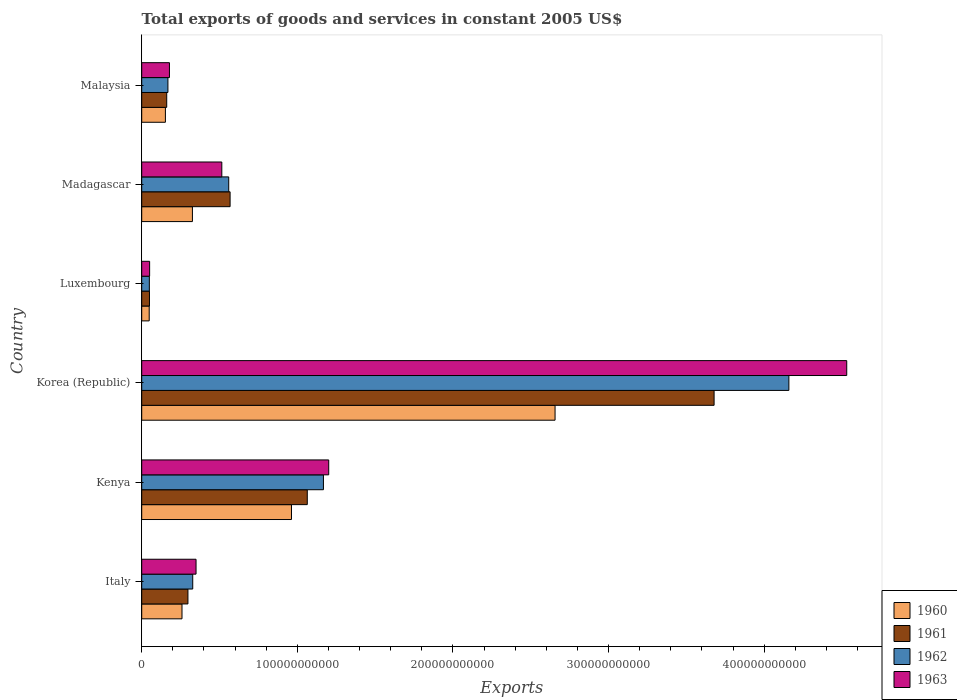How many groups of bars are there?
Your answer should be compact. 6. Are the number of bars on each tick of the Y-axis equal?
Your response must be concise. Yes. What is the label of the 2nd group of bars from the top?
Make the answer very short. Madagascar. In how many cases, is the number of bars for a given country not equal to the number of legend labels?
Offer a terse response. 0. What is the total exports of goods and services in 1960 in Luxembourg?
Provide a succinct answer. 4.81e+09. Across all countries, what is the maximum total exports of goods and services in 1961?
Your answer should be compact. 3.68e+11. Across all countries, what is the minimum total exports of goods and services in 1963?
Your response must be concise. 5.08e+09. In which country was the total exports of goods and services in 1961 maximum?
Make the answer very short. Korea (Republic). In which country was the total exports of goods and services in 1960 minimum?
Ensure brevity in your answer.  Luxembourg. What is the total total exports of goods and services in 1961 in the graph?
Make the answer very short. 5.82e+11. What is the difference between the total exports of goods and services in 1961 in Korea (Republic) and that in Luxembourg?
Offer a very short reply. 3.63e+11. What is the difference between the total exports of goods and services in 1963 in Italy and the total exports of goods and services in 1960 in Korea (Republic)?
Ensure brevity in your answer.  -2.31e+11. What is the average total exports of goods and services in 1960 per country?
Your answer should be compact. 7.34e+1. What is the difference between the total exports of goods and services in 1961 and total exports of goods and services in 1960 in Madagascar?
Your response must be concise. 2.42e+1. In how many countries, is the total exports of goods and services in 1960 greater than 100000000000 US$?
Provide a short and direct response. 1. What is the ratio of the total exports of goods and services in 1960 in Kenya to that in Luxembourg?
Ensure brevity in your answer.  20.01. Is the difference between the total exports of goods and services in 1961 in Kenya and Madagascar greater than the difference between the total exports of goods and services in 1960 in Kenya and Madagascar?
Offer a terse response. No. What is the difference between the highest and the second highest total exports of goods and services in 1963?
Your response must be concise. 3.33e+11. What is the difference between the highest and the lowest total exports of goods and services in 1963?
Keep it short and to the point. 4.48e+11. What does the 3rd bar from the top in Malaysia represents?
Provide a succinct answer. 1961. Is it the case that in every country, the sum of the total exports of goods and services in 1962 and total exports of goods and services in 1961 is greater than the total exports of goods and services in 1960?
Provide a succinct answer. Yes. How many countries are there in the graph?
Make the answer very short. 6. What is the difference between two consecutive major ticks on the X-axis?
Keep it short and to the point. 1.00e+11. Are the values on the major ticks of X-axis written in scientific E-notation?
Keep it short and to the point. No. How are the legend labels stacked?
Ensure brevity in your answer.  Vertical. What is the title of the graph?
Provide a short and direct response. Total exports of goods and services in constant 2005 US$. Does "1983" appear as one of the legend labels in the graph?
Offer a terse response. No. What is the label or title of the X-axis?
Provide a succinct answer. Exports. What is the label or title of the Y-axis?
Ensure brevity in your answer.  Country. What is the Exports of 1960 in Italy?
Offer a terse response. 2.59e+1. What is the Exports in 1961 in Italy?
Your answer should be very brief. 2.97e+1. What is the Exports of 1962 in Italy?
Your answer should be compact. 3.28e+1. What is the Exports of 1963 in Italy?
Your answer should be compact. 3.49e+1. What is the Exports of 1960 in Kenya?
Provide a succinct answer. 9.62e+1. What is the Exports in 1961 in Kenya?
Make the answer very short. 1.06e+11. What is the Exports in 1962 in Kenya?
Make the answer very short. 1.17e+11. What is the Exports of 1963 in Kenya?
Ensure brevity in your answer.  1.20e+11. What is the Exports in 1960 in Korea (Republic)?
Give a very brief answer. 2.66e+11. What is the Exports of 1961 in Korea (Republic)?
Provide a short and direct response. 3.68e+11. What is the Exports of 1962 in Korea (Republic)?
Ensure brevity in your answer.  4.16e+11. What is the Exports of 1963 in Korea (Republic)?
Your answer should be very brief. 4.53e+11. What is the Exports of 1960 in Luxembourg?
Provide a succinct answer. 4.81e+09. What is the Exports in 1961 in Luxembourg?
Offer a terse response. 4.98e+09. What is the Exports in 1962 in Luxembourg?
Give a very brief answer. 4.90e+09. What is the Exports of 1963 in Luxembourg?
Your response must be concise. 5.08e+09. What is the Exports in 1960 in Madagascar?
Your answer should be very brief. 3.26e+1. What is the Exports in 1961 in Madagascar?
Your answer should be very brief. 5.68e+1. What is the Exports in 1962 in Madagascar?
Provide a short and direct response. 5.59e+1. What is the Exports of 1963 in Madagascar?
Offer a terse response. 5.15e+1. What is the Exports of 1960 in Malaysia?
Offer a terse response. 1.52e+1. What is the Exports of 1961 in Malaysia?
Give a very brief answer. 1.61e+1. What is the Exports in 1962 in Malaysia?
Make the answer very short. 1.68e+1. What is the Exports of 1963 in Malaysia?
Keep it short and to the point. 1.78e+1. Across all countries, what is the maximum Exports of 1960?
Your answer should be very brief. 2.66e+11. Across all countries, what is the maximum Exports of 1961?
Ensure brevity in your answer.  3.68e+11. Across all countries, what is the maximum Exports in 1962?
Give a very brief answer. 4.16e+11. Across all countries, what is the maximum Exports of 1963?
Offer a very short reply. 4.53e+11. Across all countries, what is the minimum Exports of 1960?
Offer a terse response. 4.81e+09. Across all countries, what is the minimum Exports in 1961?
Your answer should be very brief. 4.98e+09. Across all countries, what is the minimum Exports in 1962?
Provide a succinct answer. 4.90e+09. Across all countries, what is the minimum Exports in 1963?
Your response must be concise. 5.08e+09. What is the total Exports of 1960 in the graph?
Give a very brief answer. 4.40e+11. What is the total Exports in 1961 in the graph?
Your answer should be very brief. 5.82e+11. What is the total Exports of 1962 in the graph?
Your answer should be very brief. 6.43e+11. What is the total Exports of 1963 in the graph?
Make the answer very short. 6.82e+11. What is the difference between the Exports of 1960 in Italy and that in Kenya?
Give a very brief answer. -7.04e+1. What is the difference between the Exports in 1961 in Italy and that in Kenya?
Ensure brevity in your answer.  -7.67e+1. What is the difference between the Exports of 1962 in Italy and that in Kenya?
Your response must be concise. -8.40e+1. What is the difference between the Exports in 1963 in Italy and that in Kenya?
Your response must be concise. -8.53e+1. What is the difference between the Exports of 1960 in Italy and that in Korea (Republic)?
Offer a terse response. -2.40e+11. What is the difference between the Exports of 1961 in Italy and that in Korea (Republic)?
Offer a very short reply. -3.38e+11. What is the difference between the Exports of 1962 in Italy and that in Korea (Republic)?
Offer a terse response. -3.83e+11. What is the difference between the Exports in 1963 in Italy and that in Korea (Republic)?
Provide a short and direct response. -4.18e+11. What is the difference between the Exports in 1960 in Italy and that in Luxembourg?
Keep it short and to the point. 2.11e+1. What is the difference between the Exports in 1961 in Italy and that in Luxembourg?
Your answer should be very brief. 2.47e+1. What is the difference between the Exports in 1962 in Italy and that in Luxembourg?
Provide a succinct answer. 2.79e+1. What is the difference between the Exports of 1963 in Italy and that in Luxembourg?
Your answer should be compact. 2.98e+1. What is the difference between the Exports of 1960 in Italy and that in Madagascar?
Offer a terse response. -6.70e+09. What is the difference between the Exports in 1961 in Italy and that in Madagascar?
Your response must be concise. -2.71e+1. What is the difference between the Exports in 1962 in Italy and that in Madagascar?
Provide a short and direct response. -2.31e+1. What is the difference between the Exports of 1963 in Italy and that in Madagascar?
Your answer should be very brief. -1.66e+1. What is the difference between the Exports in 1960 in Italy and that in Malaysia?
Give a very brief answer. 1.07e+1. What is the difference between the Exports of 1961 in Italy and that in Malaysia?
Provide a short and direct response. 1.36e+1. What is the difference between the Exports of 1962 in Italy and that in Malaysia?
Provide a succinct answer. 1.59e+1. What is the difference between the Exports of 1963 in Italy and that in Malaysia?
Keep it short and to the point. 1.71e+1. What is the difference between the Exports of 1960 in Kenya and that in Korea (Republic)?
Your answer should be compact. -1.69e+11. What is the difference between the Exports of 1961 in Kenya and that in Korea (Republic)?
Keep it short and to the point. -2.61e+11. What is the difference between the Exports of 1962 in Kenya and that in Korea (Republic)?
Provide a short and direct response. -2.99e+11. What is the difference between the Exports in 1963 in Kenya and that in Korea (Republic)?
Give a very brief answer. -3.33e+11. What is the difference between the Exports of 1960 in Kenya and that in Luxembourg?
Offer a terse response. 9.14e+1. What is the difference between the Exports in 1961 in Kenya and that in Luxembourg?
Provide a succinct answer. 1.01e+11. What is the difference between the Exports in 1962 in Kenya and that in Luxembourg?
Offer a very short reply. 1.12e+11. What is the difference between the Exports of 1963 in Kenya and that in Luxembourg?
Offer a very short reply. 1.15e+11. What is the difference between the Exports in 1960 in Kenya and that in Madagascar?
Your response must be concise. 6.37e+1. What is the difference between the Exports in 1961 in Kenya and that in Madagascar?
Give a very brief answer. 4.96e+1. What is the difference between the Exports of 1962 in Kenya and that in Madagascar?
Offer a very short reply. 6.09e+1. What is the difference between the Exports of 1963 in Kenya and that in Madagascar?
Keep it short and to the point. 6.87e+1. What is the difference between the Exports of 1960 in Kenya and that in Malaysia?
Give a very brief answer. 8.10e+1. What is the difference between the Exports in 1961 in Kenya and that in Malaysia?
Make the answer very short. 9.03e+1. What is the difference between the Exports of 1962 in Kenya and that in Malaysia?
Ensure brevity in your answer.  9.99e+1. What is the difference between the Exports in 1963 in Kenya and that in Malaysia?
Your answer should be very brief. 1.02e+11. What is the difference between the Exports in 1960 in Korea (Republic) and that in Luxembourg?
Your answer should be very brief. 2.61e+11. What is the difference between the Exports of 1961 in Korea (Republic) and that in Luxembourg?
Offer a terse response. 3.63e+11. What is the difference between the Exports in 1962 in Korea (Republic) and that in Luxembourg?
Ensure brevity in your answer.  4.11e+11. What is the difference between the Exports of 1963 in Korea (Republic) and that in Luxembourg?
Provide a short and direct response. 4.48e+11. What is the difference between the Exports of 1960 in Korea (Republic) and that in Madagascar?
Your answer should be compact. 2.33e+11. What is the difference between the Exports of 1961 in Korea (Republic) and that in Madagascar?
Give a very brief answer. 3.11e+11. What is the difference between the Exports in 1962 in Korea (Republic) and that in Madagascar?
Make the answer very short. 3.60e+11. What is the difference between the Exports in 1963 in Korea (Republic) and that in Madagascar?
Your response must be concise. 4.02e+11. What is the difference between the Exports of 1960 in Korea (Republic) and that in Malaysia?
Your response must be concise. 2.50e+11. What is the difference between the Exports of 1961 in Korea (Republic) and that in Malaysia?
Keep it short and to the point. 3.52e+11. What is the difference between the Exports of 1962 in Korea (Republic) and that in Malaysia?
Ensure brevity in your answer.  3.99e+11. What is the difference between the Exports of 1963 in Korea (Republic) and that in Malaysia?
Your response must be concise. 4.35e+11. What is the difference between the Exports in 1960 in Luxembourg and that in Madagascar?
Your answer should be compact. -2.78e+1. What is the difference between the Exports of 1961 in Luxembourg and that in Madagascar?
Keep it short and to the point. -5.18e+1. What is the difference between the Exports of 1962 in Luxembourg and that in Madagascar?
Make the answer very short. -5.10e+1. What is the difference between the Exports in 1963 in Luxembourg and that in Madagascar?
Your response must be concise. -4.64e+1. What is the difference between the Exports of 1960 in Luxembourg and that in Malaysia?
Provide a short and direct response. -1.04e+1. What is the difference between the Exports in 1961 in Luxembourg and that in Malaysia?
Your answer should be very brief. -1.11e+1. What is the difference between the Exports of 1962 in Luxembourg and that in Malaysia?
Provide a short and direct response. -1.19e+1. What is the difference between the Exports in 1963 in Luxembourg and that in Malaysia?
Give a very brief answer. -1.27e+1. What is the difference between the Exports in 1960 in Madagascar and that in Malaysia?
Ensure brevity in your answer.  1.74e+1. What is the difference between the Exports of 1961 in Madagascar and that in Malaysia?
Your response must be concise. 4.07e+1. What is the difference between the Exports of 1962 in Madagascar and that in Malaysia?
Offer a terse response. 3.91e+1. What is the difference between the Exports of 1963 in Madagascar and that in Malaysia?
Offer a very short reply. 3.36e+1. What is the difference between the Exports in 1960 in Italy and the Exports in 1961 in Kenya?
Provide a succinct answer. -8.05e+1. What is the difference between the Exports in 1960 in Italy and the Exports in 1962 in Kenya?
Your response must be concise. -9.09e+1. What is the difference between the Exports of 1960 in Italy and the Exports of 1963 in Kenya?
Offer a very short reply. -9.43e+1. What is the difference between the Exports of 1961 in Italy and the Exports of 1962 in Kenya?
Provide a short and direct response. -8.71e+1. What is the difference between the Exports of 1961 in Italy and the Exports of 1963 in Kenya?
Provide a short and direct response. -9.05e+1. What is the difference between the Exports of 1962 in Italy and the Exports of 1963 in Kenya?
Your answer should be compact. -8.74e+1. What is the difference between the Exports in 1960 in Italy and the Exports in 1961 in Korea (Republic)?
Your response must be concise. -3.42e+11. What is the difference between the Exports in 1960 in Italy and the Exports in 1962 in Korea (Republic)?
Your answer should be very brief. -3.90e+11. What is the difference between the Exports of 1960 in Italy and the Exports of 1963 in Korea (Republic)?
Your response must be concise. -4.27e+11. What is the difference between the Exports of 1961 in Italy and the Exports of 1962 in Korea (Republic)?
Your answer should be compact. -3.86e+11. What is the difference between the Exports of 1961 in Italy and the Exports of 1963 in Korea (Republic)?
Your response must be concise. -4.23e+11. What is the difference between the Exports in 1962 in Italy and the Exports in 1963 in Korea (Republic)?
Your answer should be very brief. -4.20e+11. What is the difference between the Exports of 1960 in Italy and the Exports of 1961 in Luxembourg?
Offer a terse response. 2.09e+1. What is the difference between the Exports in 1960 in Italy and the Exports in 1962 in Luxembourg?
Provide a short and direct response. 2.10e+1. What is the difference between the Exports in 1960 in Italy and the Exports in 1963 in Luxembourg?
Offer a terse response. 2.08e+1. What is the difference between the Exports in 1961 in Italy and the Exports in 1962 in Luxembourg?
Provide a succinct answer. 2.48e+1. What is the difference between the Exports in 1961 in Italy and the Exports in 1963 in Luxembourg?
Make the answer very short. 2.46e+1. What is the difference between the Exports in 1962 in Italy and the Exports in 1963 in Luxembourg?
Ensure brevity in your answer.  2.77e+1. What is the difference between the Exports of 1960 in Italy and the Exports of 1961 in Madagascar?
Offer a very short reply. -3.09e+1. What is the difference between the Exports of 1960 in Italy and the Exports of 1962 in Madagascar?
Your answer should be compact. -3.00e+1. What is the difference between the Exports in 1960 in Italy and the Exports in 1963 in Madagascar?
Your answer should be compact. -2.56e+1. What is the difference between the Exports in 1961 in Italy and the Exports in 1962 in Madagascar?
Make the answer very short. -2.62e+1. What is the difference between the Exports in 1961 in Italy and the Exports in 1963 in Madagascar?
Your answer should be very brief. -2.18e+1. What is the difference between the Exports in 1962 in Italy and the Exports in 1963 in Madagascar?
Provide a succinct answer. -1.87e+1. What is the difference between the Exports in 1960 in Italy and the Exports in 1961 in Malaysia?
Provide a short and direct response. 9.82e+09. What is the difference between the Exports in 1960 in Italy and the Exports in 1962 in Malaysia?
Provide a succinct answer. 9.05e+09. What is the difference between the Exports in 1960 in Italy and the Exports in 1963 in Malaysia?
Keep it short and to the point. 8.06e+09. What is the difference between the Exports of 1961 in Italy and the Exports of 1962 in Malaysia?
Your response must be concise. 1.29e+1. What is the difference between the Exports in 1961 in Italy and the Exports in 1963 in Malaysia?
Provide a succinct answer. 1.19e+1. What is the difference between the Exports in 1962 in Italy and the Exports in 1963 in Malaysia?
Keep it short and to the point. 1.50e+1. What is the difference between the Exports in 1960 in Kenya and the Exports in 1961 in Korea (Republic)?
Your answer should be compact. -2.72e+11. What is the difference between the Exports of 1960 in Kenya and the Exports of 1962 in Korea (Republic)?
Make the answer very short. -3.20e+11. What is the difference between the Exports of 1960 in Kenya and the Exports of 1963 in Korea (Republic)?
Provide a short and direct response. -3.57e+11. What is the difference between the Exports of 1961 in Kenya and the Exports of 1962 in Korea (Republic)?
Give a very brief answer. -3.09e+11. What is the difference between the Exports of 1961 in Kenya and the Exports of 1963 in Korea (Republic)?
Give a very brief answer. -3.47e+11. What is the difference between the Exports in 1962 in Kenya and the Exports in 1963 in Korea (Republic)?
Your response must be concise. -3.36e+11. What is the difference between the Exports in 1960 in Kenya and the Exports in 1961 in Luxembourg?
Your response must be concise. 9.13e+1. What is the difference between the Exports of 1960 in Kenya and the Exports of 1962 in Luxembourg?
Your answer should be compact. 9.13e+1. What is the difference between the Exports of 1960 in Kenya and the Exports of 1963 in Luxembourg?
Offer a very short reply. 9.12e+1. What is the difference between the Exports in 1961 in Kenya and the Exports in 1962 in Luxembourg?
Ensure brevity in your answer.  1.01e+11. What is the difference between the Exports in 1961 in Kenya and the Exports in 1963 in Luxembourg?
Offer a terse response. 1.01e+11. What is the difference between the Exports in 1962 in Kenya and the Exports in 1963 in Luxembourg?
Provide a succinct answer. 1.12e+11. What is the difference between the Exports of 1960 in Kenya and the Exports of 1961 in Madagascar?
Make the answer very short. 3.94e+1. What is the difference between the Exports of 1960 in Kenya and the Exports of 1962 in Madagascar?
Offer a terse response. 4.03e+1. What is the difference between the Exports in 1960 in Kenya and the Exports in 1963 in Madagascar?
Your response must be concise. 4.48e+1. What is the difference between the Exports in 1961 in Kenya and the Exports in 1962 in Madagascar?
Your answer should be compact. 5.05e+1. What is the difference between the Exports of 1961 in Kenya and the Exports of 1963 in Madagascar?
Make the answer very short. 5.49e+1. What is the difference between the Exports in 1962 in Kenya and the Exports in 1963 in Madagascar?
Your response must be concise. 6.53e+1. What is the difference between the Exports in 1960 in Kenya and the Exports in 1961 in Malaysia?
Give a very brief answer. 8.02e+1. What is the difference between the Exports in 1960 in Kenya and the Exports in 1962 in Malaysia?
Provide a succinct answer. 7.94e+1. What is the difference between the Exports in 1960 in Kenya and the Exports in 1963 in Malaysia?
Ensure brevity in your answer.  7.84e+1. What is the difference between the Exports of 1961 in Kenya and the Exports of 1962 in Malaysia?
Provide a succinct answer. 8.96e+1. What is the difference between the Exports of 1961 in Kenya and the Exports of 1963 in Malaysia?
Make the answer very short. 8.86e+1. What is the difference between the Exports of 1962 in Kenya and the Exports of 1963 in Malaysia?
Ensure brevity in your answer.  9.89e+1. What is the difference between the Exports of 1960 in Korea (Republic) and the Exports of 1961 in Luxembourg?
Make the answer very short. 2.61e+11. What is the difference between the Exports in 1960 in Korea (Republic) and the Exports in 1962 in Luxembourg?
Your answer should be very brief. 2.61e+11. What is the difference between the Exports of 1960 in Korea (Republic) and the Exports of 1963 in Luxembourg?
Keep it short and to the point. 2.61e+11. What is the difference between the Exports in 1961 in Korea (Republic) and the Exports in 1962 in Luxembourg?
Provide a succinct answer. 3.63e+11. What is the difference between the Exports of 1961 in Korea (Republic) and the Exports of 1963 in Luxembourg?
Ensure brevity in your answer.  3.63e+11. What is the difference between the Exports in 1962 in Korea (Republic) and the Exports in 1963 in Luxembourg?
Provide a short and direct response. 4.11e+11. What is the difference between the Exports of 1960 in Korea (Republic) and the Exports of 1961 in Madagascar?
Your answer should be compact. 2.09e+11. What is the difference between the Exports in 1960 in Korea (Republic) and the Exports in 1962 in Madagascar?
Provide a succinct answer. 2.10e+11. What is the difference between the Exports in 1960 in Korea (Republic) and the Exports in 1963 in Madagascar?
Make the answer very short. 2.14e+11. What is the difference between the Exports of 1961 in Korea (Republic) and the Exports of 1962 in Madagascar?
Keep it short and to the point. 3.12e+11. What is the difference between the Exports of 1961 in Korea (Republic) and the Exports of 1963 in Madagascar?
Offer a very short reply. 3.16e+11. What is the difference between the Exports of 1962 in Korea (Republic) and the Exports of 1963 in Madagascar?
Give a very brief answer. 3.64e+11. What is the difference between the Exports in 1960 in Korea (Republic) and the Exports in 1961 in Malaysia?
Offer a terse response. 2.50e+11. What is the difference between the Exports in 1960 in Korea (Republic) and the Exports in 1962 in Malaysia?
Keep it short and to the point. 2.49e+11. What is the difference between the Exports in 1960 in Korea (Republic) and the Exports in 1963 in Malaysia?
Provide a succinct answer. 2.48e+11. What is the difference between the Exports in 1961 in Korea (Republic) and the Exports in 1962 in Malaysia?
Offer a terse response. 3.51e+11. What is the difference between the Exports of 1961 in Korea (Republic) and the Exports of 1963 in Malaysia?
Give a very brief answer. 3.50e+11. What is the difference between the Exports in 1962 in Korea (Republic) and the Exports in 1963 in Malaysia?
Offer a terse response. 3.98e+11. What is the difference between the Exports in 1960 in Luxembourg and the Exports in 1961 in Madagascar?
Keep it short and to the point. -5.20e+1. What is the difference between the Exports of 1960 in Luxembourg and the Exports of 1962 in Madagascar?
Make the answer very short. -5.11e+1. What is the difference between the Exports in 1960 in Luxembourg and the Exports in 1963 in Madagascar?
Offer a very short reply. -4.67e+1. What is the difference between the Exports in 1961 in Luxembourg and the Exports in 1962 in Madagascar?
Keep it short and to the point. -5.09e+1. What is the difference between the Exports in 1961 in Luxembourg and the Exports in 1963 in Madagascar?
Offer a terse response. -4.65e+1. What is the difference between the Exports in 1962 in Luxembourg and the Exports in 1963 in Madagascar?
Your answer should be very brief. -4.66e+1. What is the difference between the Exports in 1960 in Luxembourg and the Exports in 1961 in Malaysia?
Keep it short and to the point. -1.13e+1. What is the difference between the Exports in 1960 in Luxembourg and the Exports in 1962 in Malaysia?
Offer a very short reply. -1.20e+1. What is the difference between the Exports of 1960 in Luxembourg and the Exports of 1963 in Malaysia?
Offer a terse response. -1.30e+1. What is the difference between the Exports in 1961 in Luxembourg and the Exports in 1962 in Malaysia?
Keep it short and to the point. -1.19e+1. What is the difference between the Exports of 1961 in Luxembourg and the Exports of 1963 in Malaysia?
Ensure brevity in your answer.  -1.28e+1. What is the difference between the Exports of 1962 in Luxembourg and the Exports of 1963 in Malaysia?
Offer a terse response. -1.29e+1. What is the difference between the Exports in 1960 in Madagascar and the Exports in 1961 in Malaysia?
Your answer should be compact. 1.65e+1. What is the difference between the Exports of 1960 in Madagascar and the Exports of 1962 in Malaysia?
Provide a short and direct response. 1.57e+1. What is the difference between the Exports of 1960 in Madagascar and the Exports of 1963 in Malaysia?
Offer a terse response. 1.48e+1. What is the difference between the Exports in 1961 in Madagascar and the Exports in 1962 in Malaysia?
Provide a short and direct response. 4.00e+1. What is the difference between the Exports of 1961 in Madagascar and the Exports of 1963 in Malaysia?
Give a very brief answer. 3.90e+1. What is the difference between the Exports in 1962 in Madagascar and the Exports in 1963 in Malaysia?
Your answer should be very brief. 3.81e+1. What is the average Exports of 1960 per country?
Give a very brief answer. 7.34e+1. What is the average Exports of 1961 per country?
Your response must be concise. 9.70e+1. What is the average Exports in 1962 per country?
Your answer should be compact. 1.07e+11. What is the average Exports in 1963 per country?
Provide a succinct answer. 1.14e+11. What is the difference between the Exports in 1960 and Exports in 1961 in Italy?
Provide a succinct answer. -3.82e+09. What is the difference between the Exports of 1960 and Exports of 1962 in Italy?
Offer a very short reply. -6.90e+09. What is the difference between the Exports in 1960 and Exports in 1963 in Italy?
Your response must be concise. -9.02e+09. What is the difference between the Exports of 1961 and Exports of 1962 in Italy?
Make the answer very short. -3.08e+09. What is the difference between the Exports of 1961 and Exports of 1963 in Italy?
Keep it short and to the point. -5.20e+09. What is the difference between the Exports of 1962 and Exports of 1963 in Italy?
Your response must be concise. -2.13e+09. What is the difference between the Exports in 1960 and Exports in 1961 in Kenya?
Offer a terse response. -1.01e+1. What is the difference between the Exports of 1960 and Exports of 1962 in Kenya?
Give a very brief answer. -2.05e+1. What is the difference between the Exports in 1960 and Exports in 1963 in Kenya?
Make the answer very short. -2.39e+1. What is the difference between the Exports in 1961 and Exports in 1962 in Kenya?
Your answer should be compact. -1.04e+1. What is the difference between the Exports in 1961 and Exports in 1963 in Kenya?
Keep it short and to the point. -1.38e+1. What is the difference between the Exports of 1962 and Exports of 1963 in Kenya?
Keep it short and to the point. -3.39e+09. What is the difference between the Exports of 1960 and Exports of 1961 in Korea (Republic)?
Keep it short and to the point. -1.02e+11. What is the difference between the Exports in 1960 and Exports in 1962 in Korea (Republic)?
Ensure brevity in your answer.  -1.50e+11. What is the difference between the Exports of 1960 and Exports of 1963 in Korea (Republic)?
Your response must be concise. -1.87e+11. What is the difference between the Exports of 1961 and Exports of 1962 in Korea (Republic)?
Keep it short and to the point. -4.81e+1. What is the difference between the Exports of 1961 and Exports of 1963 in Korea (Republic)?
Provide a short and direct response. -8.52e+1. What is the difference between the Exports of 1962 and Exports of 1963 in Korea (Republic)?
Keep it short and to the point. -3.72e+1. What is the difference between the Exports of 1960 and Exports of 1961 in Luxembourg?
Provide a succinct answer. -1.68e+08. What is the difference between the Exports in 1960 and Exports in 1962 in Luxembourg?
Provide a succinct answer. -8.82e+07. What is the difference between the Exports of 1960 and Exports of 1963 in Luxembourg?
Your answer should be compact. -2.73e+08. What is the difference between the Exports of 1961 and Exports of 1962 in Luxembourg?
Your response must be concise. 7.94e+07. What is the difference between the Exports in 1961 and Exports in 1963 in Luxembourg?
Your answer should be compact. -1.05e+08. What is the difference between the Exports of 1962 and Exports of 1963 in Luxembourg?
Keep it short and to the point. -1.85e+08. What is the difference between the Exports of 1960 and Exports of 1961 in Madagascar?
Make the answer very short. -2.42e+1. What is the difference between the Exports of 1960 and Exports of 1962 in Madagascar?
Provide a short and direct response. -2.33e+1. What is the difference between the Exports of 1960 and Exports of 1963 in Madagascar?
Provide a succinct answer. -1.89e+1. What is the difference between the Exports in 1961 and Exports in 1962 in Madagascar?
Give a very brief answer. 8.87e+08. What is the difference between the Exports of 1961 and Exports of 1963 in Madagascar?
Provide a succinct answer. 5.32e+09. What is the difference between the Exports in 1962 and Exports in 1963 in Madagascar?
Keep it short and to the point. 4.44e+09. What is the difference between the Exports in 1960 and Exports in 1961 in Malaysia?
Make the answer very short. -8.42e+08. What is the difference between the Exports in 1960 and Exports in 1962 in Malaysia?
Give a very brief answer. -1.61e+09. What is the difference between the Exports of 1960 and Exports of 1963 in Malaysia?
Your answer should be very brief. -2.60e+09. What is the difference between the Exports in 1961 and Exports in 1962 in Malaysia?
Provide a succinct answer. -7.72e+08. What is the difference between the Exports of 1961 and Exports of 1963 in Malaysia?
Provide a succinct answer. -1.76e+09. What is the difference between the Exports of 1962 and Exports of 1963 in Malaysia?
Provide a succinct answer. -9.85e+08. What is the ratio of the Exports in 1960 in Italy to that in Kenya?
Offer a very short reply. 0.27. What is the ratio of the Exports of 1961 in Italy to that in Kenya?
Your answer should be very brief. 0.28. What is the ratio of the Exports of 1962 in Italy to that in Kenya?
Offer a terse response. 0.28. What is the ratio of the Exports of 1963 in Italy to that in Kenya?
Provide a succinct answer. 0.29. What is the ratio of the Exports in 1960 in Italy to that in Korea (Republic)?
Ensure brevity in your answer.  0.1. What is the ratio of the Exports of 1961 in Italy to that in Korea (Republic)?
Your answer should be very brief. 0.08. What is the ratio of the Exports of 1962 in Italy to that in Korea (Republic)?
Give a very brief answer. 0.08. What is the ratio of the Exports in 1963 in Italy to that in Korea (Republic)?
Your response must be concise. 0.08. What is the ratio of the Exports of 1960 in Italy to that in Luxembourg?
Offer a very short reply. 5.38. What is the ratio of the Exports of 1961 in Italy to that in Luxembourg?
Offer a very short reply. 5.97. What is the ratio of the Exports of 1962 in Italy to that in Luxembourg?
Provide a succinct answer. 6.69. What is the ratio of the Exports in 1963 in Italy to that in Luxembourg?
Offer a terse response. 6.87. What is the ratio of the Exports in 1960 in Italy to that in Madagascar?
Make the answer very short. 0.79. What is the ratio of the Exports of 1961 in Italy to that in Madagascar?
Give a very brief answer. 0.52. What is the ratio of the Exports of 1962 in Italy to that in Madagascar?
Keep it short and to the point. 0.59. What is the ratio of the Exports of 1963 in Italy to that in Madagascar?
Provide a succinct answer. 0.68. What is the ratio of the Exports in 1960 in Italy to that in Malaysia?
Offer a very short reply. 1.7. What is the ratio of the Exports in 1961 in Italy to that in Malaysia?
Give a very brief answer. 1.85. What is the ratio of the Exports in 1962 in Italy to that in Malaysia?
Ensure brevity in your answer.  1.95. What is the ratio of the Exports of 1963 in Italy to that in Malaysia?
Offer a very short reply. 1.96. What is the ratio of the Exports of 1960 in Kenya to that in Korea (Republic)?
Ensure brevity in your answer.  0.36. What is the ratio of the Exports in 1961 in Kenya to that in Korea (Republic)?
Provide a short and direct response. 0.29. What is the ratio of the Exports in 1962 in Kenya to that in Korea (Republic)?
Your answer should be very brief. 0.28. What is the ratio of the Exports in 1963 in Kenya to that in Korea (Republic)?
Provide a succinct answer. 0.27. What is the ratio of the Exports in 1960 in Kenya to that in Luxembourg?
Your answer should be very brief. 20.01. What is the ratio of the Exports in 1961 in Kenya to that in Luxembourg?
Provide a short and direct response. 21.38. What is the ratio of the Exports in 1962 in Kenya to that in Luxembourg?
Offer a very short reply. 23.84. What is the ratio of the Exports of 1963 in Kenya to that in Luxembourg?
Provide a short and direct response. 23.64. What is the ratio of the Exports of 1960 in Kenya to that in Madagascar?
Provide a succinct answer. 2.95. What is the ratio of the Exports of 1961 in Kenya to that in Madagascar?
Your answer should be compact. 1.87. What is the ratio of the Exports of 1962 in Kenya to that in Madagascar?
Offer a terse response. 2.09. What is the ratio of the Exports of 1963 in Kenya to that in Madagascar?
Ensure brevity in your answer.  2.33. What is the ratio of the Exports in 1960 in Kenya to that in Malaysia?
Provide a short and direct response. 6.32. What is the ratio of the Exports in 1961 in Kenya to that in Malaysia?
Provide a succinct answer. 6.62. What is the ratio of the Exports of 1962 in Kenya to that in Malaysia?
Make the answer very short. 6.94. What is the ratio of the Exports of 1963 in Kenya to that in Malaysia?
Make the answer very short. 6.74. What is the ratio of the Exports in 1960 in Korea (Republic) to that in Luxembourg?
Your answer should be compact. 55.23. What is the ratio of the Exports in 1961 in Korea (Republic) to that in Luxembourg?
Your answer should be very brief. 73.91. What is the ratio of the Exports in 1962 in Korea (Republic) to that in Luxembourg?
Offer a terse response. 84.92. What is the ratio of the Exports of 1963 in Korea (Republic) to that in Luxembourg?
Give a very brief answer. 89.15. What is the ratio of the Exports in 1960 in Korea (Republic) to that in Madagascar?
Provide a short and direct response. 8.15. What is the ratio of the Exports in 1961 in Korea (Republic) to that in Madagascar?
Your response must be concise. 6.48. What is the ratio of the Exports in 1962 in Korea (Republic) to that in Madagascar?
Your answer should be compact. 7.44. What is the ratio of the Exports of 1963 in Korea (Republic) to that in Madagascar?
Your answer should be compact. 8.8. What is the ratio of the Exports of 1960 in Korea (Republic) to that in Malaysia?
Ensure brevity in your answer.  17.45. What is the ratio of the Exports of 1961 in Korea (Republic) to that in Malaysia?
Make the answer very short. 22.9. What is the ratio of the Exports of 1962 in Korea (Republic) to that in Malaysia?
Provide a succinct answer. 24.7. What is the ratio of the Exports of 1963 in Korea (Republic) to that in Malaysia?
Your answer should be very brief. 25.42. What is the ratio of the Exports of 1960 in Luxembourg to that in Madagascar?
Your answer should be compact. 0.15. What is the ratio of the Exports in 1961 in Luxembourg to that in Madagascar?
Keep it short and to the point. 0.09. What is the ratio of the Exports in 1962 in Luxembourg to that in Madagascar?
Keep it short and to the point. 0.09. What is the ratio of the Exports of 1963 in Luxembourg to that in Madagascar?
Give a very brief answer. 0.1. What is the ratio of the Exports of 1960 in Luxembourg to that in Malaysia?
Your response must be concise. 0.32. What is the ratio of the Exports in 1961 in Luxembourg to that in Malaysia?
Ensure brevity in your answer.  0.31. What is the ratio of the Exports of 1962 in Luxembourg to that in Malaysia?
Give a very brief answer. 0.29. What is the ratio of the Exports in 1963 in Luxembourg to that in Malaysia?
Make the answer very short. 0.29. What is the ratio of the Exports of 1960 in Madagascar to that in Malaysia?
Your answer should be compact. 2.14. What is the ratio of the Exports in 1961 in Madagascar to that in Malaysia?
Ensure brevity in your answer.  3.54. What is the ratio of the Exports in 1962 in Madagascar to that in Malaysia?
Provide a short and direct response. 3.32. What is the ratio of the Exports in 1963 in Madagascar to that in Malaysia?
Make the answer very short. 2.89. What is the difference between the highest and the second highest Exports of 1960?
Keep it short and to the point. 1.69e+11. What is the difference between the highest and the second highest Exports of 1961?
Keep it short and to the point. 2.61e+11. What is the difference between the highest and the second highest Exports in 1962?
Make the answer very short. 2.99e+11. What is the difference between the highest and the second highest Exports in 1963?
Keep it short and to the point. 3.33e+11. What is the difference between the highest and the lowest Exports of 1960?
Keep it short and to the point. 2.61e+11. What is the difference between the highest and the lowest Exports of 1961?
Ensure brevity in your answer.  3.63e+11. What is the difference between the highest and the lowest Exports in 1962?
Offer a very short reply. 4.11e+11. What is the difference between the highest and the lowest Exports in 1963?
Keep it short and to the point. 4.48e+11. 